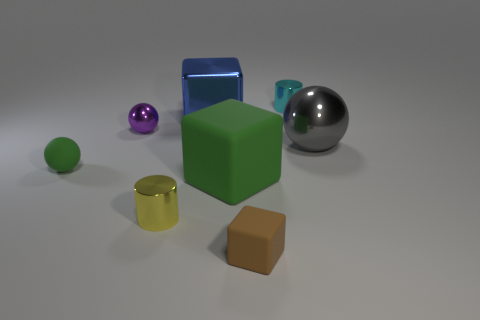Which objects in the image have a reflective surface? The objects with reflective surfaces in this image are the silver sphere and the transparent blue cube. You can observe reflections on their surfaces that show attention to detail in the rendering process. 